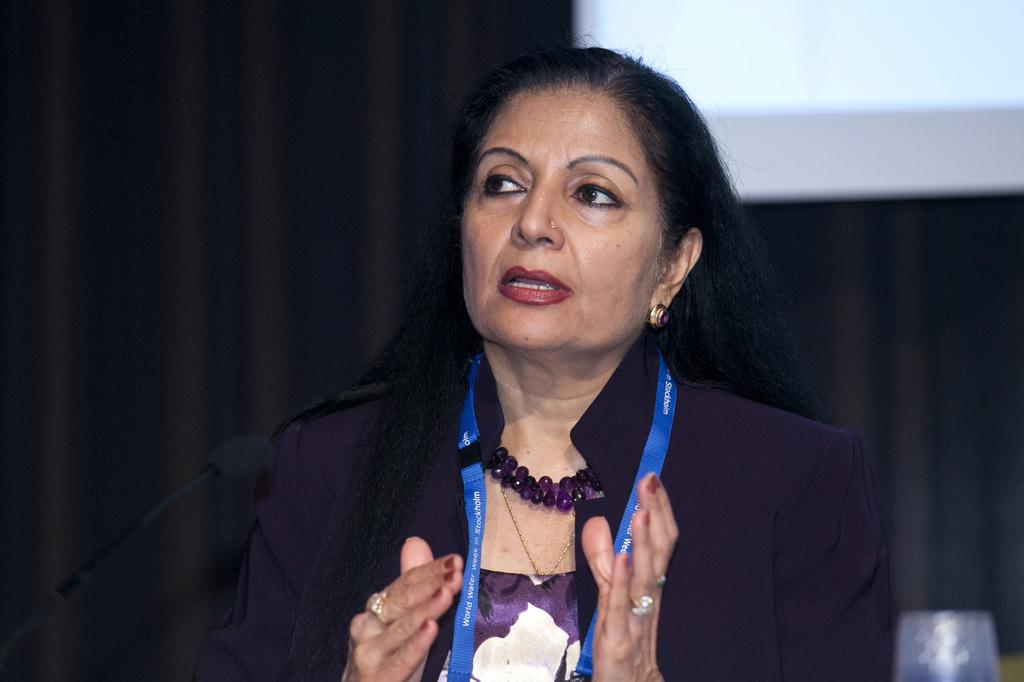Who is present in the image? There is a woman in the image. What is attached to the woman? The woman has a tag. What device is visible in the image? There is a microphone (mike) in the image. What can be seen in the background of the image? There appears to be a projector screen in the background of the image. What type of sand can be seen on the plate in the image? There is no sand or plate present in the image. What story is the woman telling using the microphone? The image does not provide any information about a story being told, so we cannot determine what the woman might be saying. 